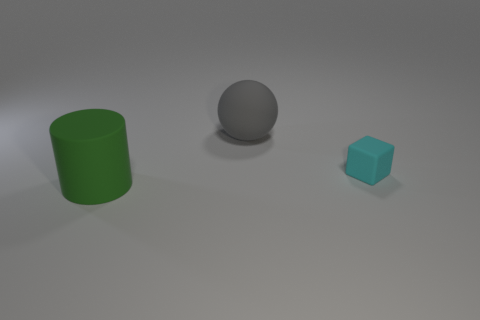Add 2 big gray matte objects. How many objects exist? 5 Subtract all cubes. How many objects are left? 2 Add 3 large objects. How many large objects are left? 5 Add 2 big green objects. How many big green objects exist? 3 Subtract 0 gray cylinders. How many objects are left? 3 Subtract all small gray matte cylinders. Subtract all large green cylinders. How many objects are left? 2 